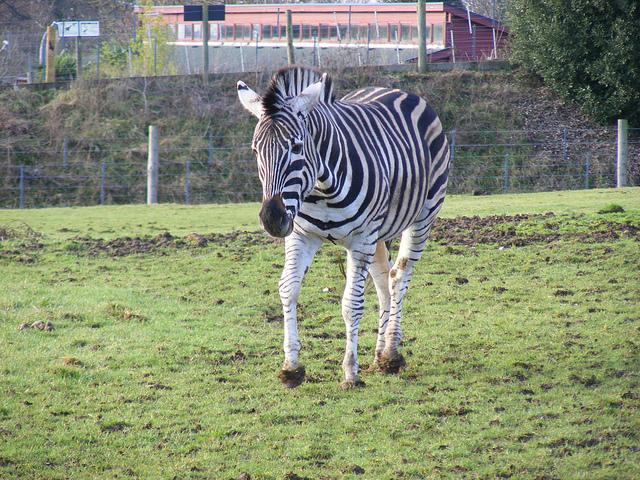What time of day is this?
Short answer required. Afternoon. What is at the edge of the field?
Keep it brief. Fence. Where is the zebra?
Be succinct. Field. 